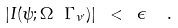<formula> <loc_0><loc_0><loc_500><loc_500>| I ( \psi ; \Omega \ \Gamma _ { \nu ^ { \prime } } ) | \ < \ \epsilon \ \ .</formula> 